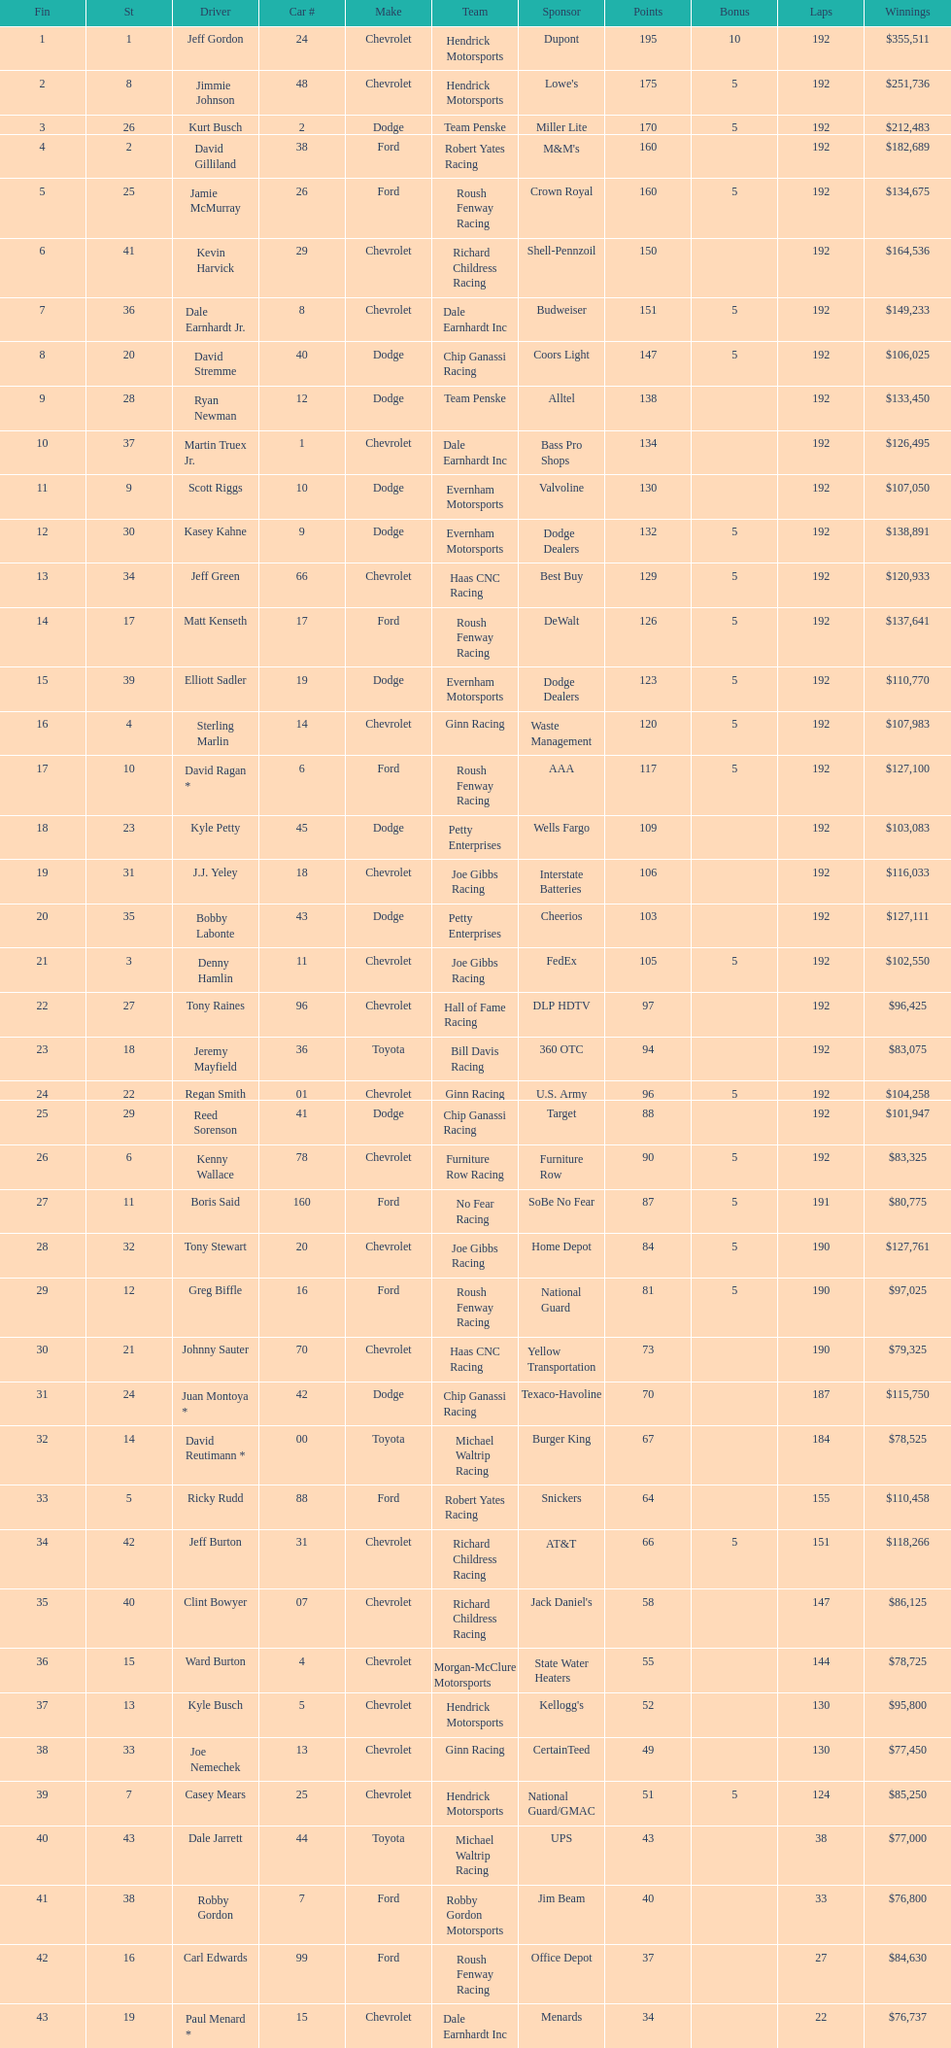Who is first in number of winnings on this list? Jeff Gordon. 